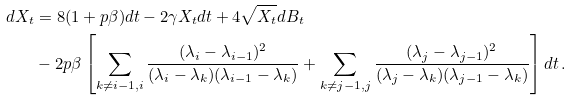Convert formula to latex. <formula><loc_0><loc_0><loc_500><loc_500>d X _ { t } & = 8 ( 1 + p \beta ) d t - 2 \gamma X _ { t } d t + 4 \sqrt { X _ { t } } d B _ { t } \\ & - 2 p \beta \left [ \sum _ { k \not = i - 1 , i } \frac { ( \lambda _ { i } - \lambda _ { i - 1 } ) ^ { 2 } } { ( \lambda _ { i } - \lambda _ { k } ) ( \lambda _ { i - 1 } - \lambda _ { k } ) } + \sum _ { k \not = j - 1 , j } \frac { ( \lambda _ { j } - \lambda _ { j - 1 } ) ^ { 2 } } { ( \lambda _ { j } - \lambda _ { k } ) ( \lambda _ { j - 1 } - \lambda _ { k } ) } \right ] d t \, .</formula> 